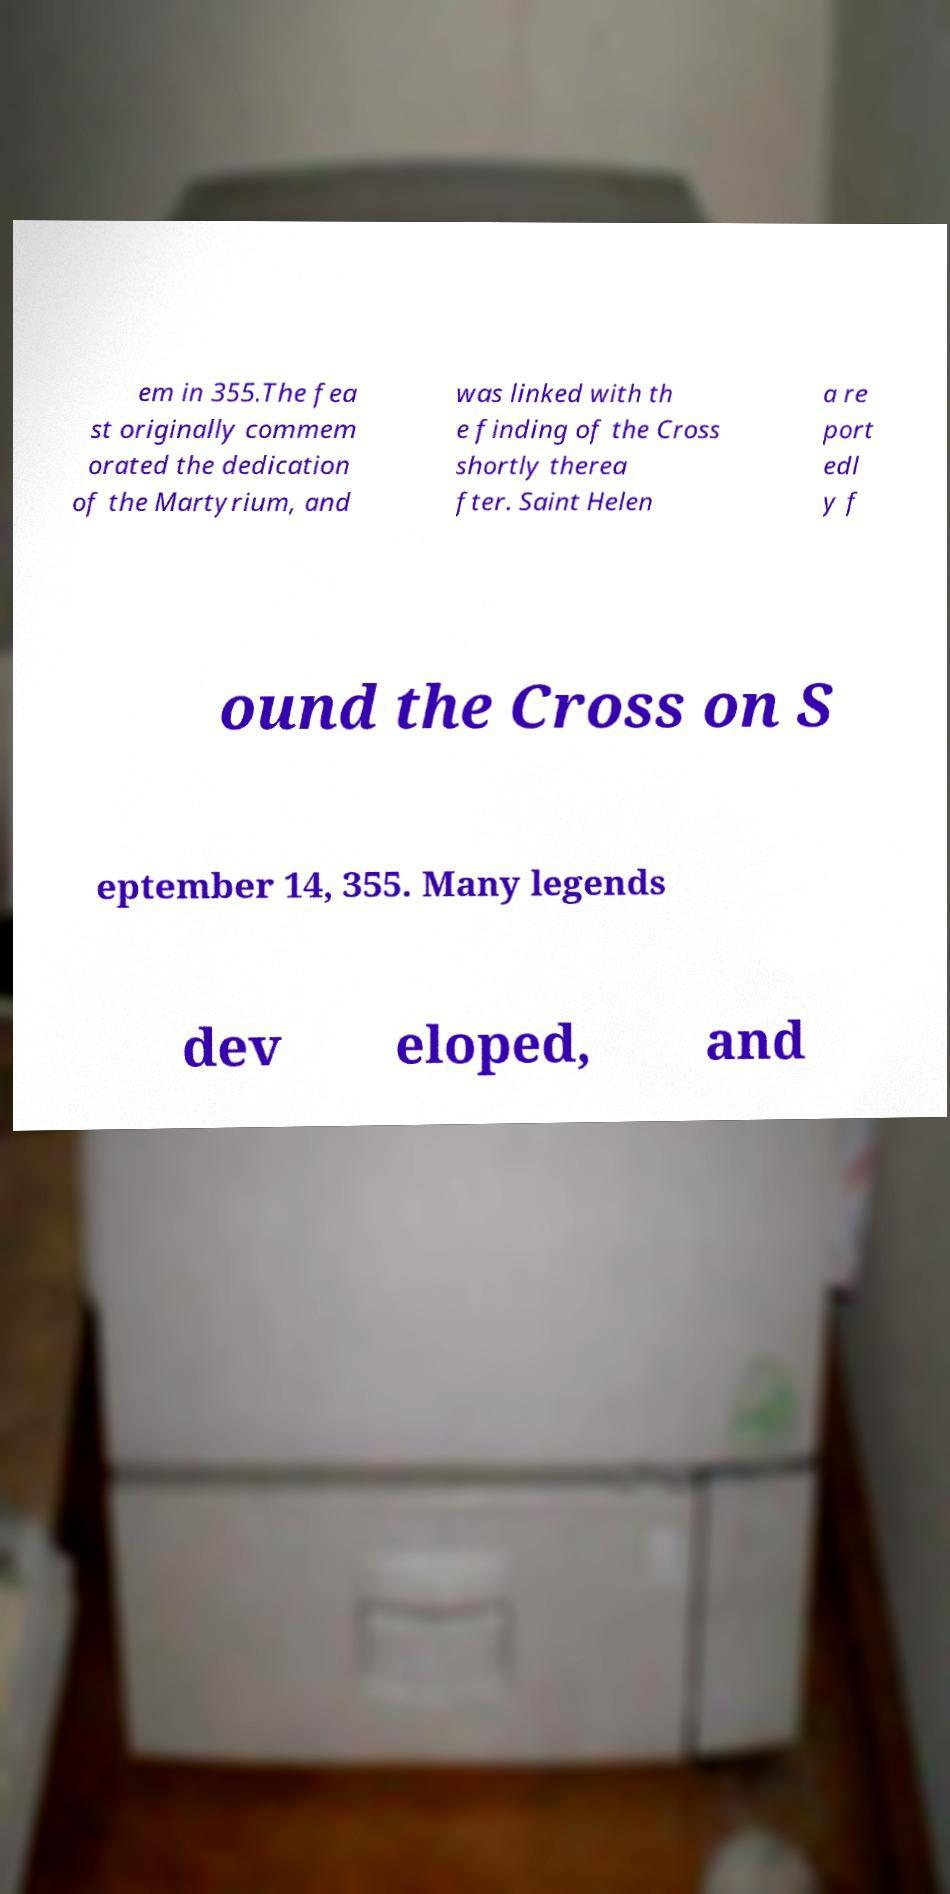Can you read and provide the text displayed in the image?This photo seems to have some interesting text. Can you extract and type it out for me? em in 355.The fea st originally commem orated the dedication of the Martyrium, and was linked with th e finding of the Cross shortly therea fter. Saint Helen a re port edl y f ound the Cross on S eptember 14, 355. Many legends dev eloped, and 